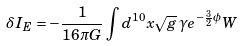<formula> <loc_0><loc_0><loc_500><loc_500>\delta I _ { E } = - \frac { 1 } { 1 6 \pi G } \int d ^ { 1 0 } x \sqrt { g } \, \gamma e ^ { - \frac { 3 } { 2 } \phi } W</formula> 